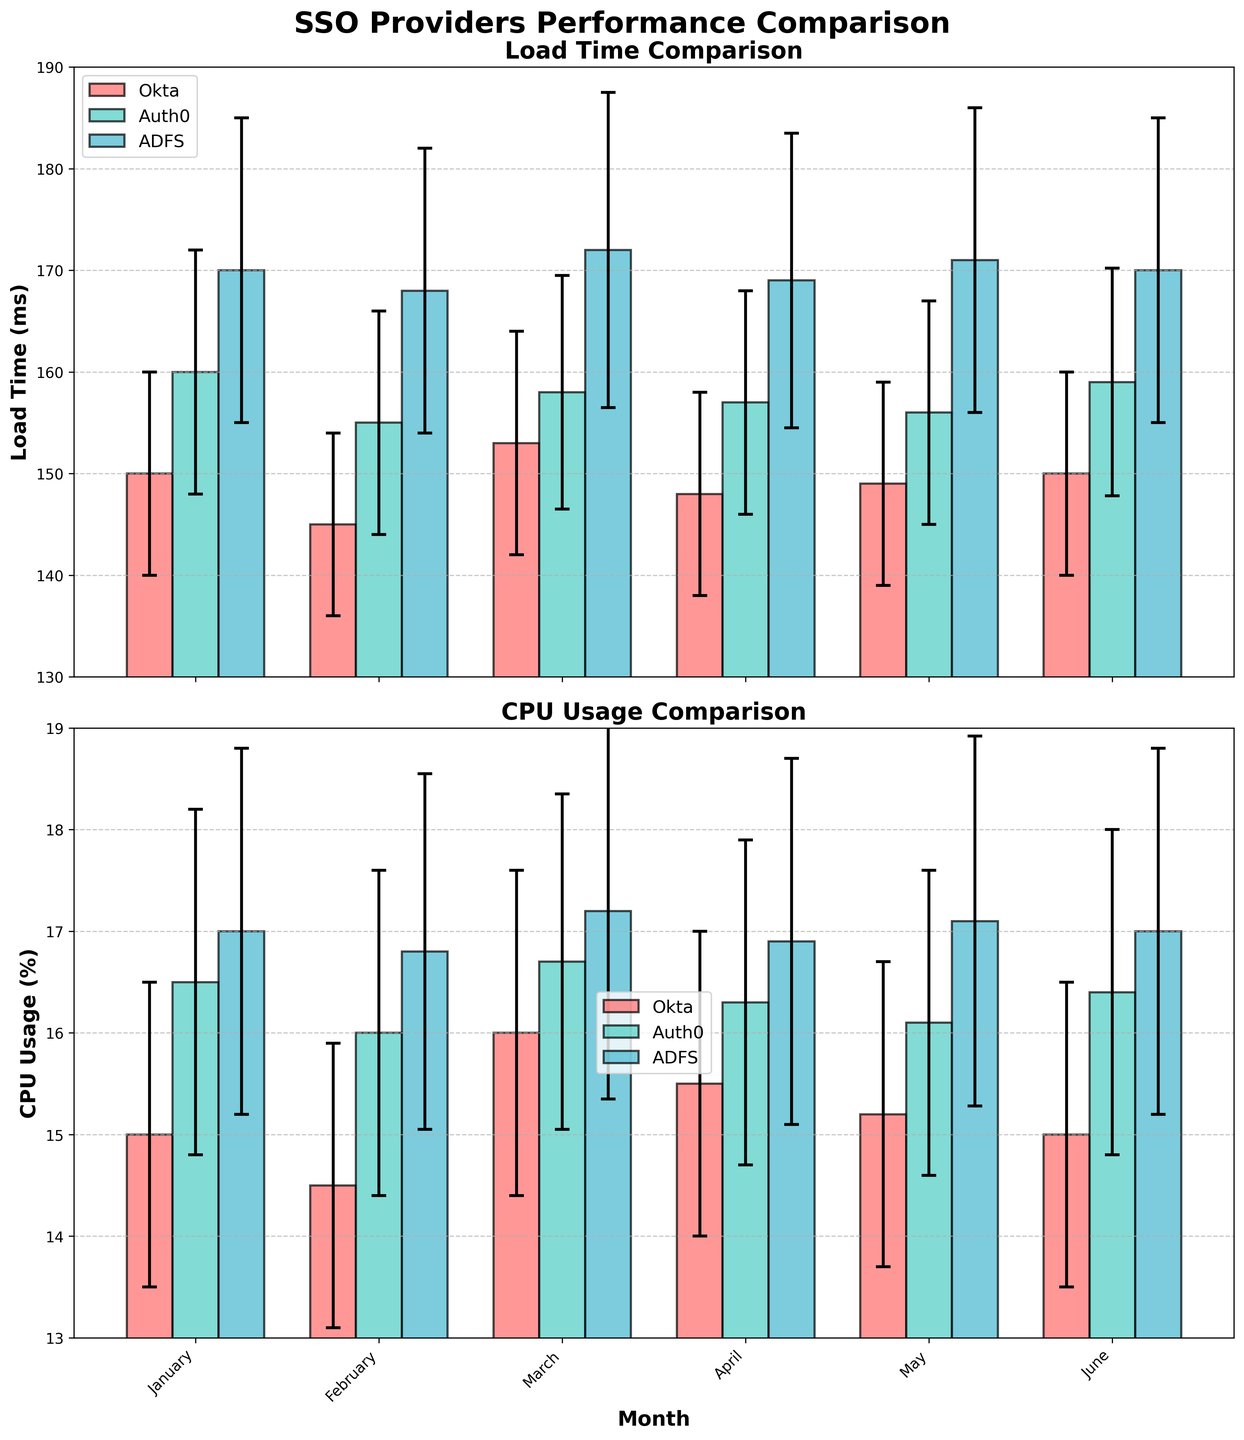What's the title of the overall figure? The main title is prominently displayed at the top center of the figure, which reads "SSO Providers Performance Comparison".
Answer: SSO Providers Performance Comparison Which SSO provider has the highest average load time across the given months? By visually inspecting the Load Time bars for each provider over the six months, it’s evident that ADFS consistently has higher load times compared to Okta and Auth0.
Answer: ADFS What is the load time for Okta in March and its error margin? The bar for Okta in March is observed at around 153 ms with an error margin of ±11 ms, indicating the possible range is from 142 ms to 164 ms.
Answer: 153 ms with ±11 ms How does CPU usage for Auth0 in February compare to its CPU usage in June? For Auth0, the CPU usage in February is displayed at 16%, while in June, it shows 16.4%. Therefore, the CPU usage increased by 0.4% from February to June.
Answer: Increased by 0.4% What is the range of CPU usage values for ADFS in April, considering the error bars? ADFS’s CPU usage in April is shown at 16.9%, with an error margin of ±1.8%. Thus, the range is from 15.1% to 18.7%.
Answer: 15.1% to 18.7% Which month shows the lowest load time for any SSO provider, and what is it? By examining the shortest bars in the Load Time plot, Okta in February has the lowest load time at 145 ms.
Answer: February, 145 ms What is the difference in average load time between Okta and Auth0? Summing the monthly load times for Okta (150 + 145 + 153 + 148 + 149 + 150) gives 895 ms, and for Auth0 (160 + 155 + 158 + 157 + 156 + 159) gives 945 ms. The average for Okta is 895/6 = 149.17 ms, and for Auth0, it is 945/6 = 157.5 ms. The difference is 157.5 - 149.17 = 8.33 ms.
Answer: 8.33 ms Which provider shows the greatest variability in load times over the months? By comparing the lengths of the error bars across providers, ADFS has larger error margins, indicating greater variability in load times.
Answer: ADFS 